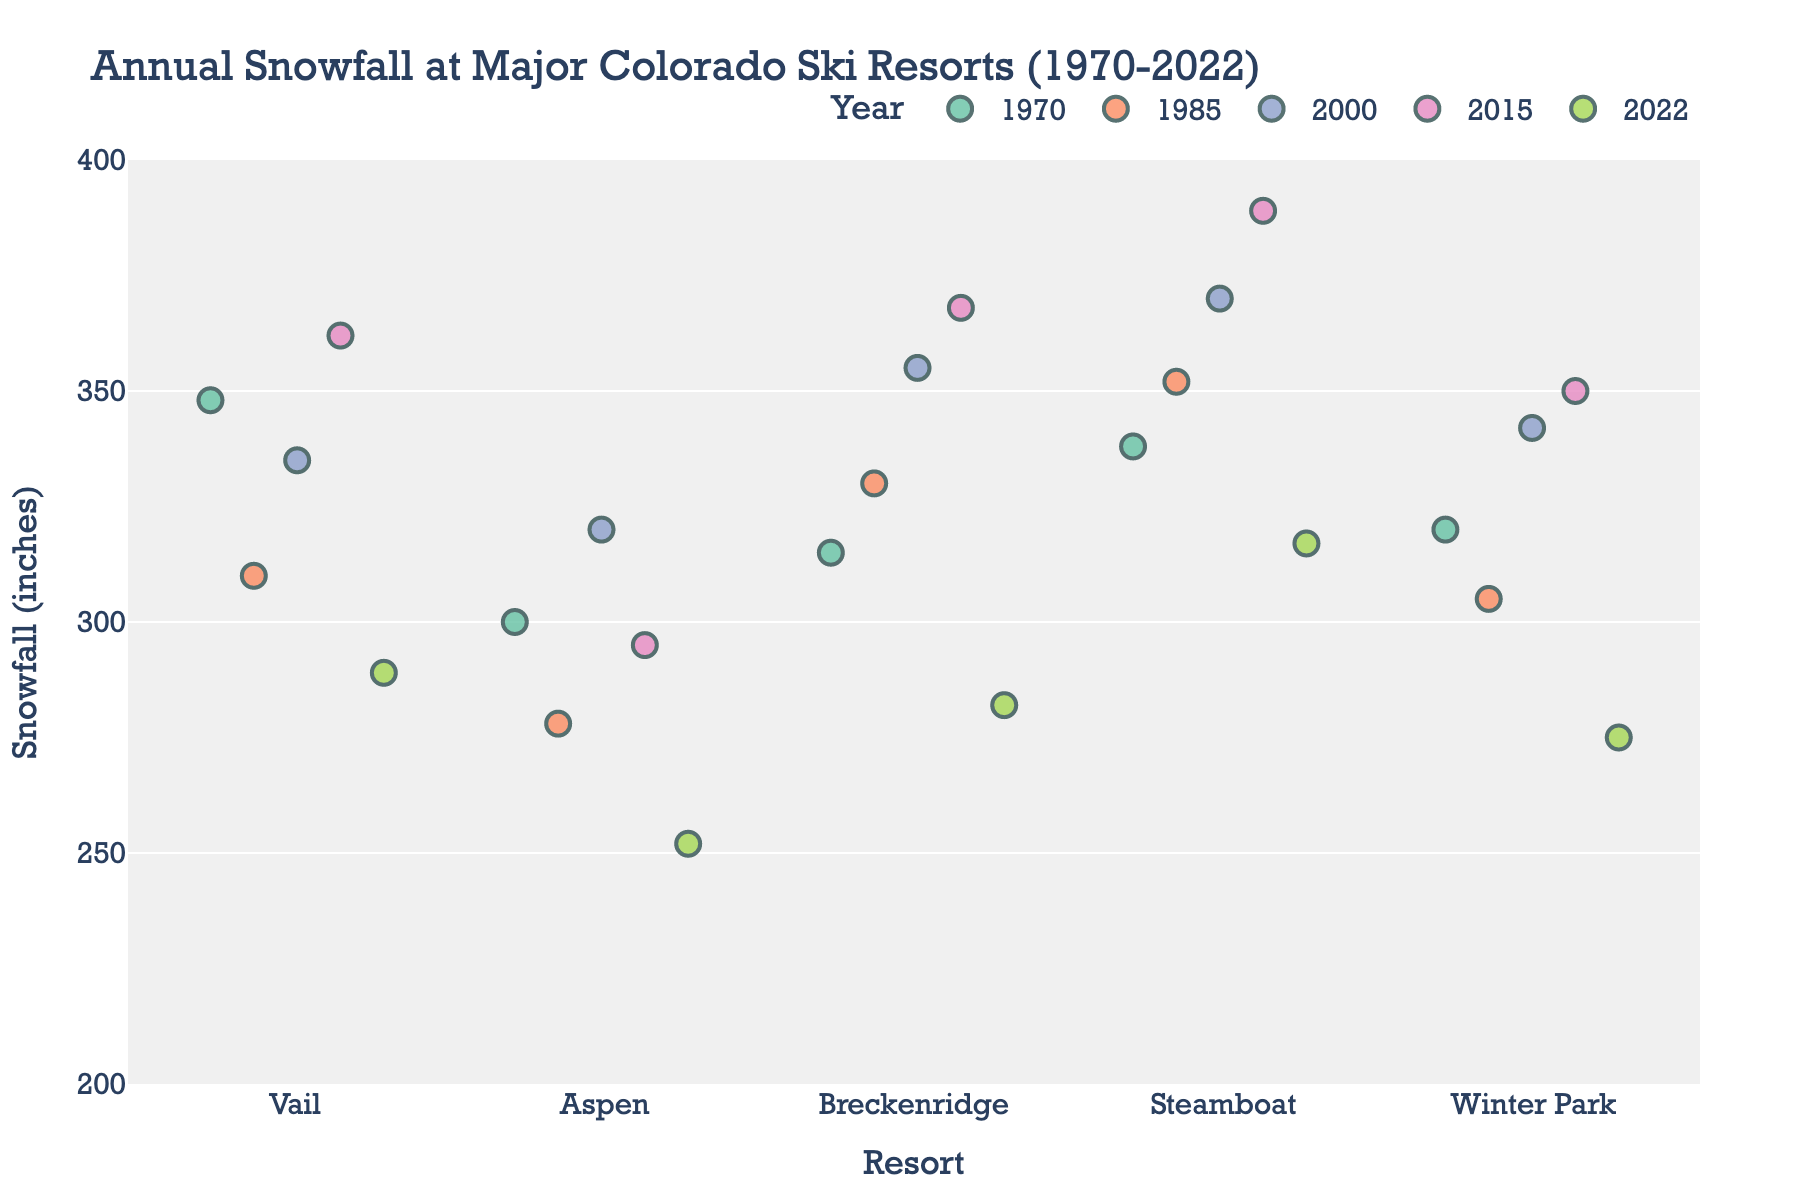What's the title of the figure? The title of the figure is displayed at the top and provides an overview of the data being presented.
Answer: Annual Snowfall at Major Colorado Ski Resorts (1970-2022) Which years are represented in the figure? The figure legend lists the years, which can be seen in the different colors used to represent them.
Answer: 1970, 1985, 2000, 2015, 2022 What is the range of snowfall amounts shown on the y-axis? The y-axis of the figure has ticks marking the range from the minimum to the maximum snowfall amounts.
Answer: 200 to 400 inches Which resort has the highest snowfall in 2015? Locate the data points for 2015 and compare their positions along the y-axis to find the highest one.
Answer: Steamboat What's the difference in snowfall amounts between Vail and Aspen in 2000? Find the 2000 data points for Vail and Aspen and subtract the lower value from the higher value.
Answer: 15 inches How has Steamboat's snowfall changed from 1970 to 2022? Compare the data points for Steamboat in 1970 and 2022, noting whether the snowfall increased or decreased.
Answer: Increased from 338 inches to 317 inches Which resort experienced the largest decrease in snowfall from 2000 to 2022? For each resort, calculate the difference in snowfall between 2000 and 2022, then determine the largest decrease.
Answer: Winter Park What is the average snowfall for Breckenridge across the given years? Add the snowfall amounts for Breckenridge for all provided years and divide by the number of years.
Answer: 330 inches Do any resorts show a generally increasing trend in snowfall over time? Observe the general direction of data points over time for each resort to identify any upward trends.
Answer: Steamboat In which year did Winter Park have less snowfall compared to the previous recorded year in the dataset? Compare the snowfall amounts of Winter Park in consecutive years to find any decreases.
Answer: 1985 